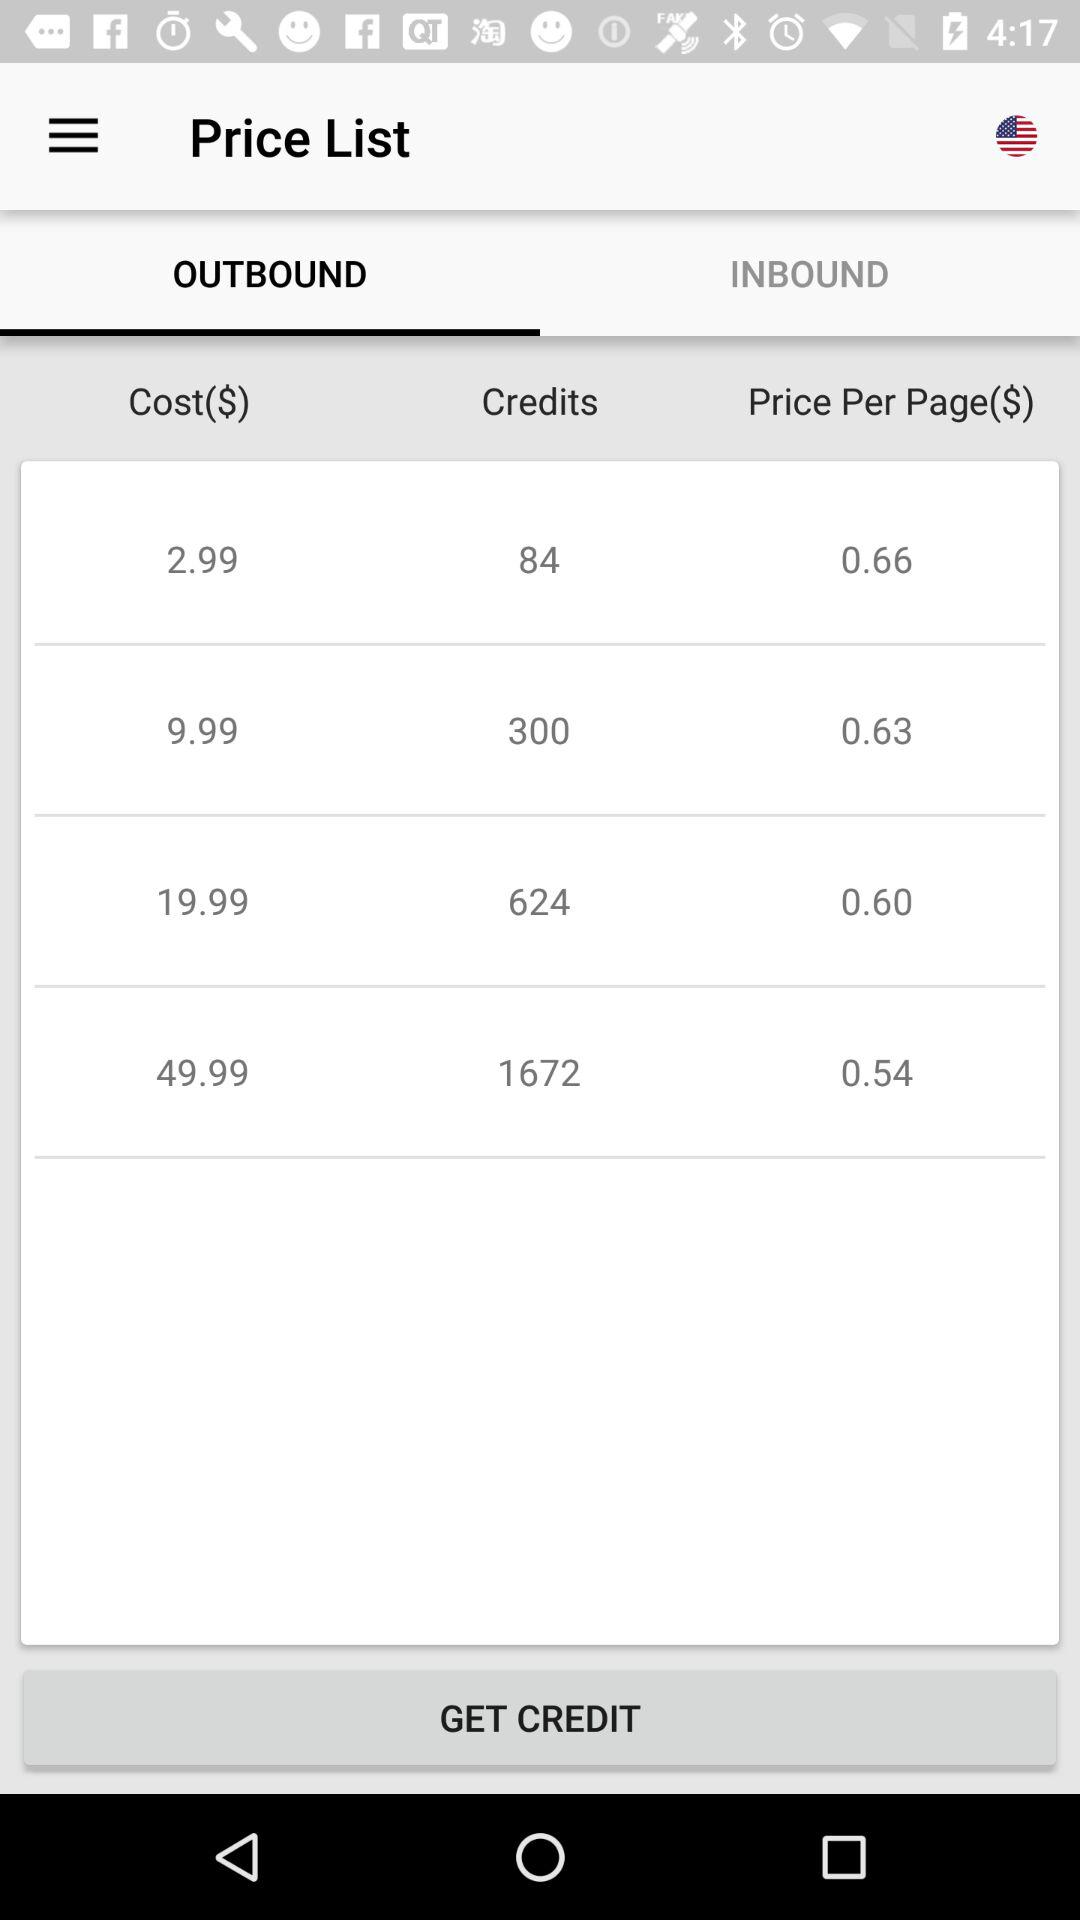What is the price of 300 credits? The price is $9.99. 